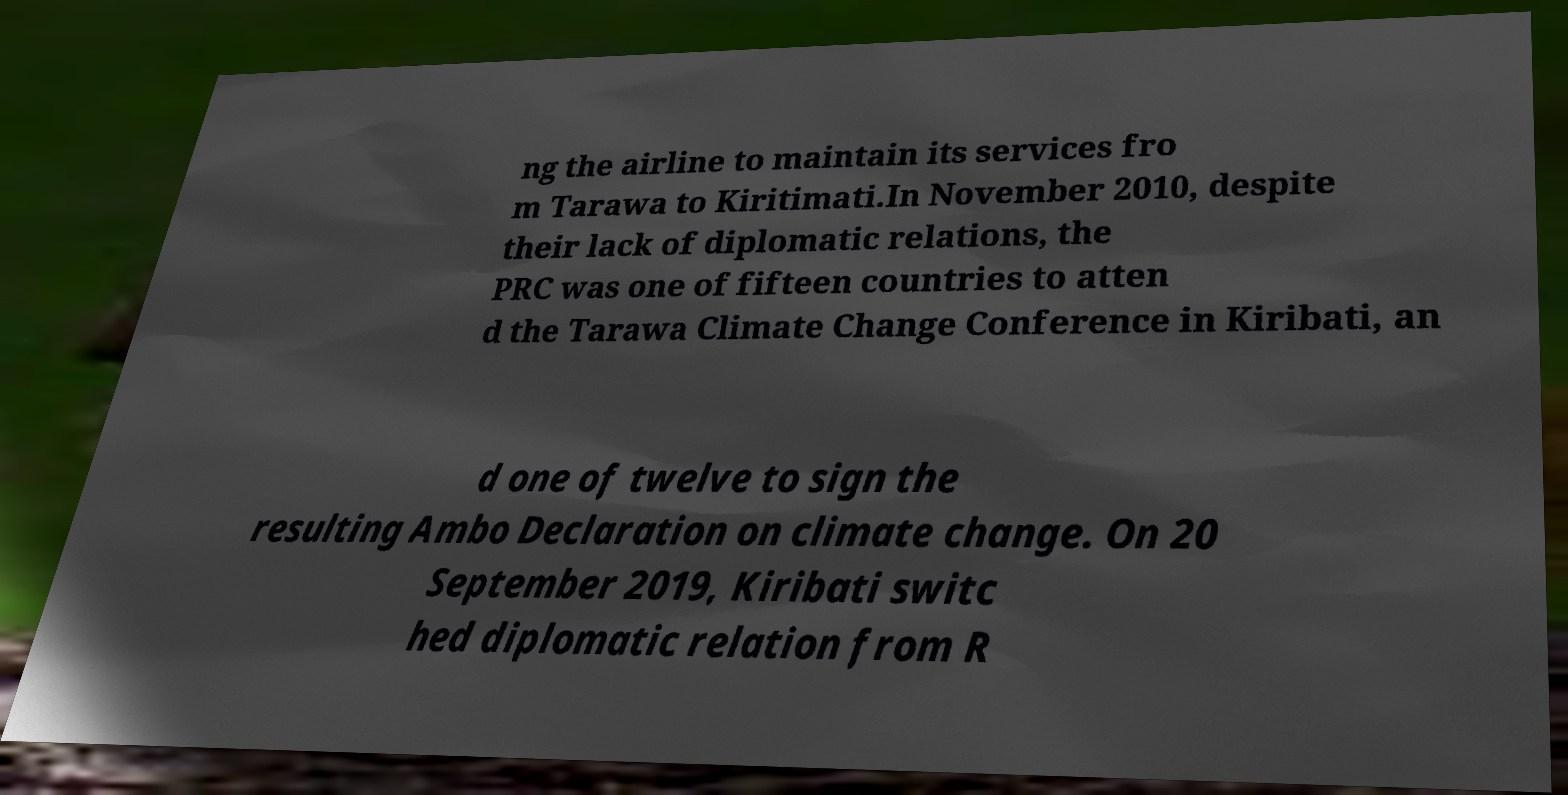Can you accurately transcribe the text from the provided image for me? ng the airline to maintain its services fro m Tarawa to Kiritimati.In November 2010, despite their lack of diplomatic relations, the PRC was one of fifteen countries to atten d the Tarawa Climate Change Conference in Kiribati, an d one of twelve to sign the resulting Ambo Declaration on climate change. On 20 September 2019, Kiribati switc hed diplomatic relation from R 